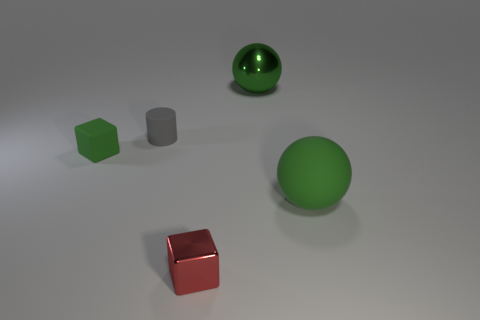What material is the big object left of the green rubber object to the right of the shiny object that is in front of the gray cylinder?
Give a very brief answer. Metal. There is a object that is in front of the large green rubber object; does it have the same shape as the tiny green rubber thing?
Your response must be concise. Yes. There is a large object that is behind the big rubber sphere; what material is it?
Give a very brief answer. Metal. What number of metal things are either small green things or big purple blocks?
Your answer should be compact. 0. Are there any other gray matte objects that have the same size as the gray rubber object?
Offer a very short reply. No. Is the number of green things behind the green block greater than the number of red shiny spheres?
Your response must be concise. Yes. What number of big things are either rubber balls or cubes?
Your answer should be compact. 1. How many other large green objects have the same shape as the big rubber thing?
Ensure brevity in your answer.  1. What is the green ball that is to the left of the big green thing right of the metallic ball made of?
Offer a very short reply. Metal. What size is the green rubber object that is on the right side of the small shiny object?
Offer a terse response. Large. 